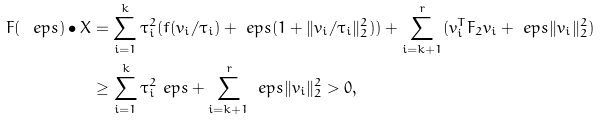<formula> <loc_0><loc_0><loc_500><loc_500>F ( \ e p s ) \bullet X & = \sum _ { i = 1 } ^ { k } \tau _ { i } ^ { 2 } ( f ( v _ { i } / \tau _ { i } ) + \ e p s ( 1 + \| v _ { i } / \tau _ { i } \| _ { 2 } ^ { 2 } ) ) + \sum _ { i = k + 1 } ^ { r } ( v _ { i } ^ { T } F _ { 2 } v _ { i } + \ e p s \| v _ { i } \| _ { 2 } ^ { 2 } ) \\ & \geq \sum _ { i = 1 } ^ { k } \tau _ { i } ^ { 2 } \ e p s + \sum _ { i = k + 1 } ^ { r } \ e p s \| v _ { i } \| _ { 2 } ^ { 2 } > 0 ,</formula> 